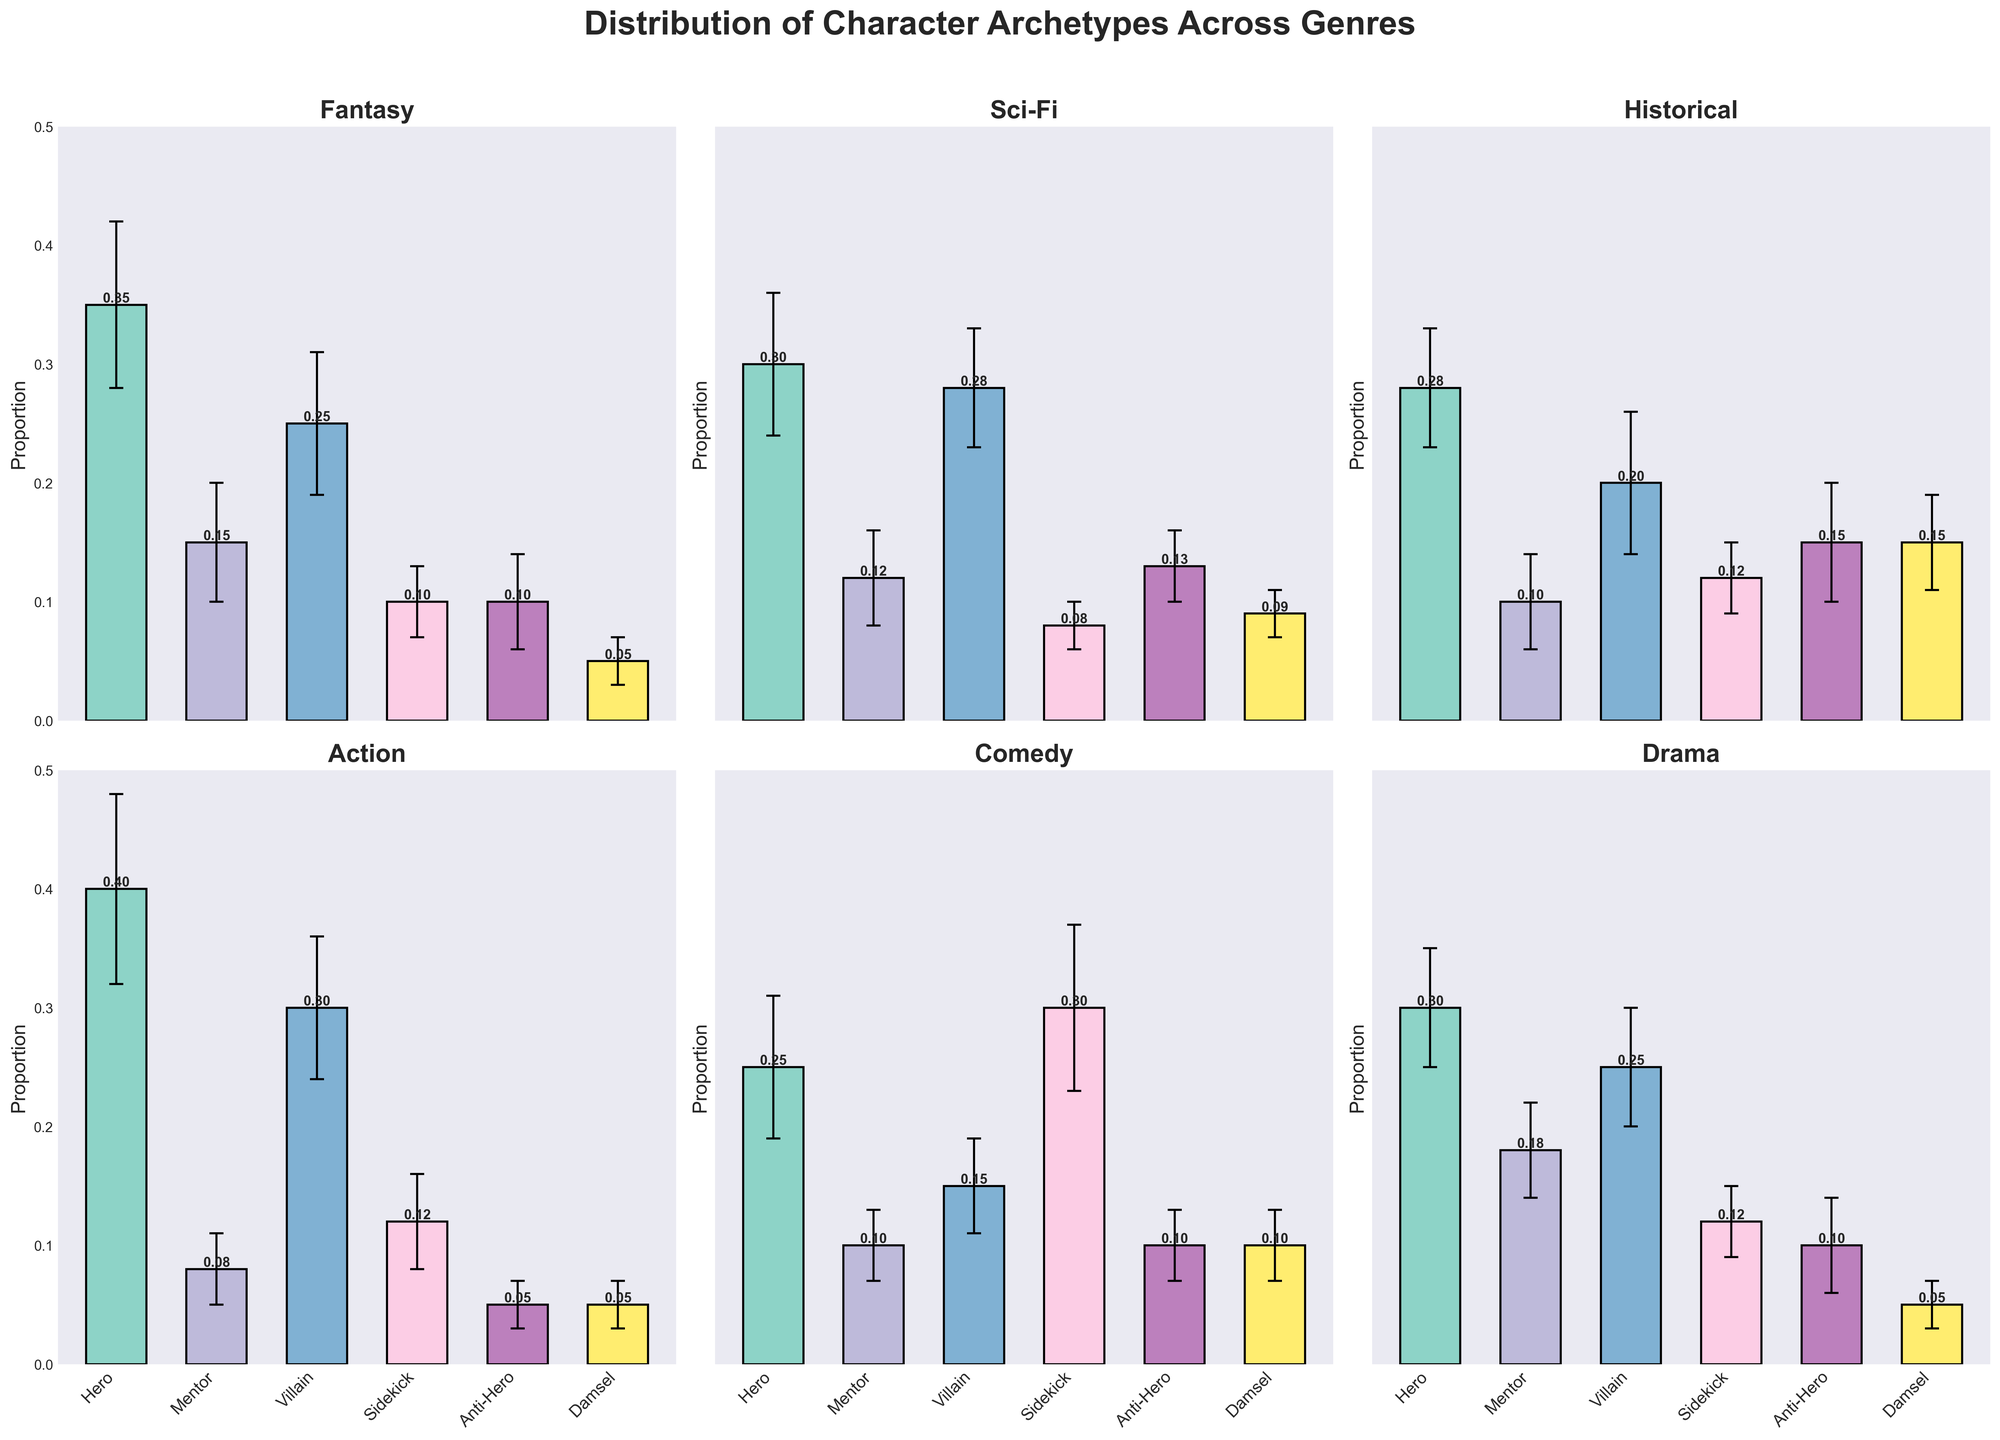What is the title of the figure? The title of the figure is displayed prominently at the top. It reads, "Distribution of Character Archetypes Across Genres".
Answer: Distribution of Character Archetypes Across Genres Which genre has the highest mean value for the 'Hero' archetype? To determine this, we look at the height of the bars representing the 'Hero' archetype across all genres. The 'Hero' bar in Action is the tallest among all.
Answer: Action What is the mean proportion of the 'Anti-Hero' archetype in Drama, and how does it compare to the mean in Sci-Fi? The mean proportion of 'Anti-Hero' in Drama is 0.10, and in Sci-Fi, it is 0.13. To compare, since 0.10 (Drama) is less than 0.13 (Sci-Fi).
Answer: Less in Drama Which genre shows the smallest standard deviation for any archetype and what is that archetype? By checking the error bars, the smallest standard deviation (smallest error bar) is for the 'Damsel' archetype in Fantasy which has a standard deviation of 0.02.
Answer: Fantasy, Damsel How does the 'Villain' archetype in Comedy compare with the same archetype in Historical in terms of mean proportion? The 'Villain' archetype mean in Comedy is 0.15, while in Historical it is 0.20. Thus, the 'Villain' archetype is less prevalent in Comedy than in Historical.
Answer: Less in Comedy What is the difference in the mean proportions of the 'Mentor' archetype between Fantasy and Drama? The mean proportion of 'Mentor' in Fantasy is 0.15 and in Drama is 0.18. The difference is calculated as 0.18 - 0.15 = 0.03.
Answer: 0.03 Which archetype has the highest mean proportion in Comedy and does this archetype have a high standard deviation? The 'Sidekick' archetype has the highest mean proportion in Comedy with a mean of 0.30. It also has a high standard deviation of 0.07.
Answer: Sidekick, Yes In which genre does the 'Hero' archetype have the smallest mean proportion, and what is that value? By comparing the 'Hero' means across all genres, the smallest mean proportion is in Comedy, where it is 0.25.
Answer: Comedy, 0.25 